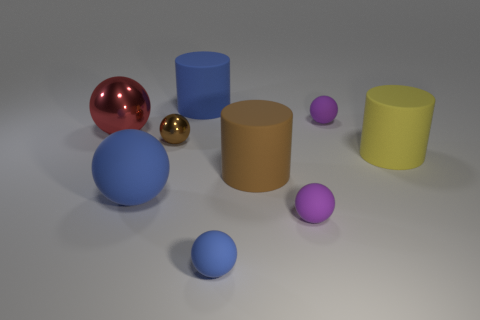Subtract all shiny balls. How many balls are left? 4 Subtract all brown cylinders. How many purple balls are left? 2 Subtract all purple spheres. How many spheres are left? 4 Subtract all cylinders. How many objects are left? 6 Subtract 2 spheres. How many spheres are left? 4 Add 9 green spheres. How many green spheres exist? 9 Subtract 1 red spheres. How many objects are left? 8 Subtract all green spheres. Subtract all red cylinders. How many spheres are left? 6 Subtract all large blue cylinders. Subtract all small brown metallic things. How many objects are left? 7 Add 3 big yellow cylinders. How many big yellow cylinders are left? 4 